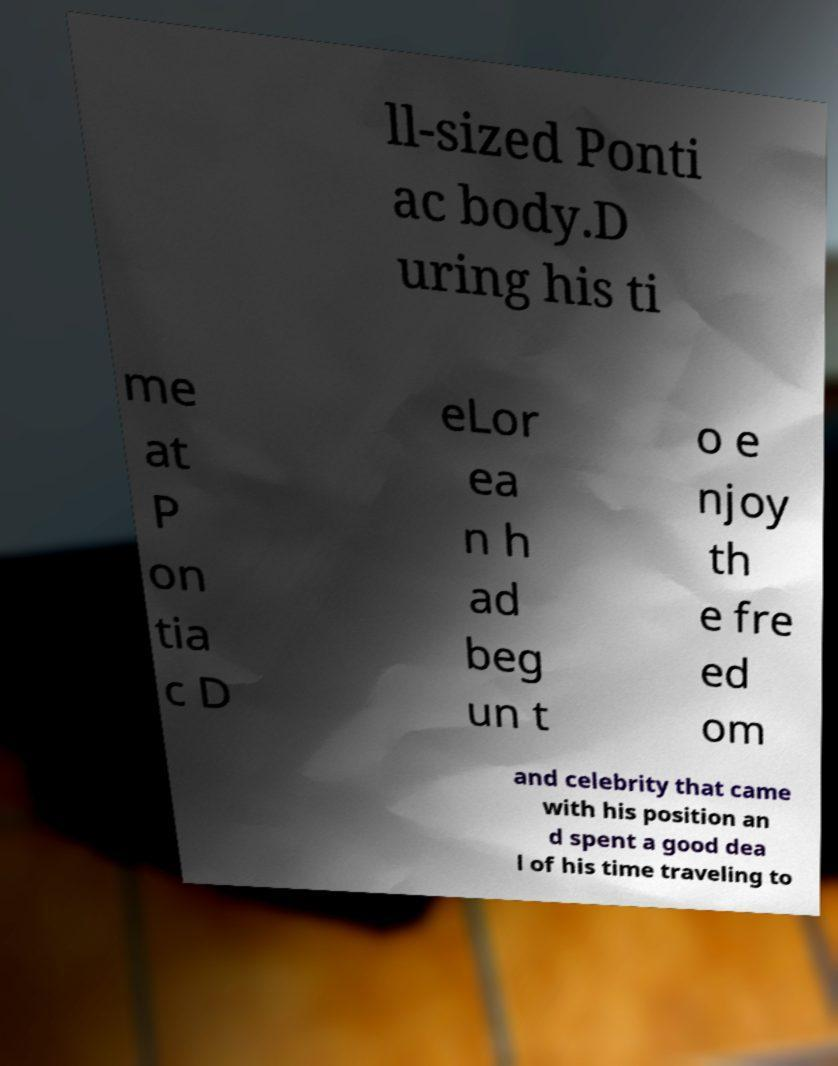Could you extract and type out the text from this image? ll-sized Ponti ac body.D uring his ti me at P on tia c D eLor ea n h ad beg un t o e njoy th e fre ed om and celebrity that came with his position an d spent a good dea l of his time traveling to 